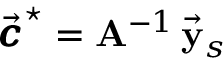Convert formula to latex. <formula><loc_0><loc_0><loc_500><loc_500>\vec { \pm b { c } } ^ { ^ { * } } = { A } ^ { - 1 } \, \vec { y } _ { s }</formula> 